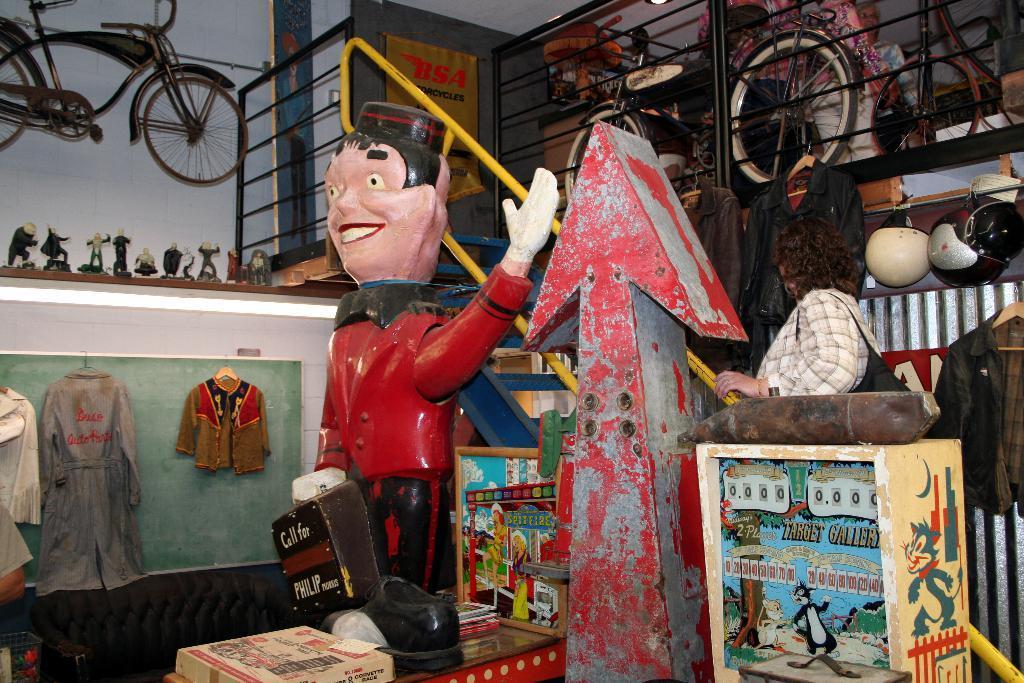Could you give a brief overview of what you see in this image? In this image we can see group of toys. In the foreground we can see a box on the table. In the right side of the image we can see a woman carrying a bag. In the background, we can see clothes , helmets on the wall, group of bicycles placed on the ground , staircase and some lights. 